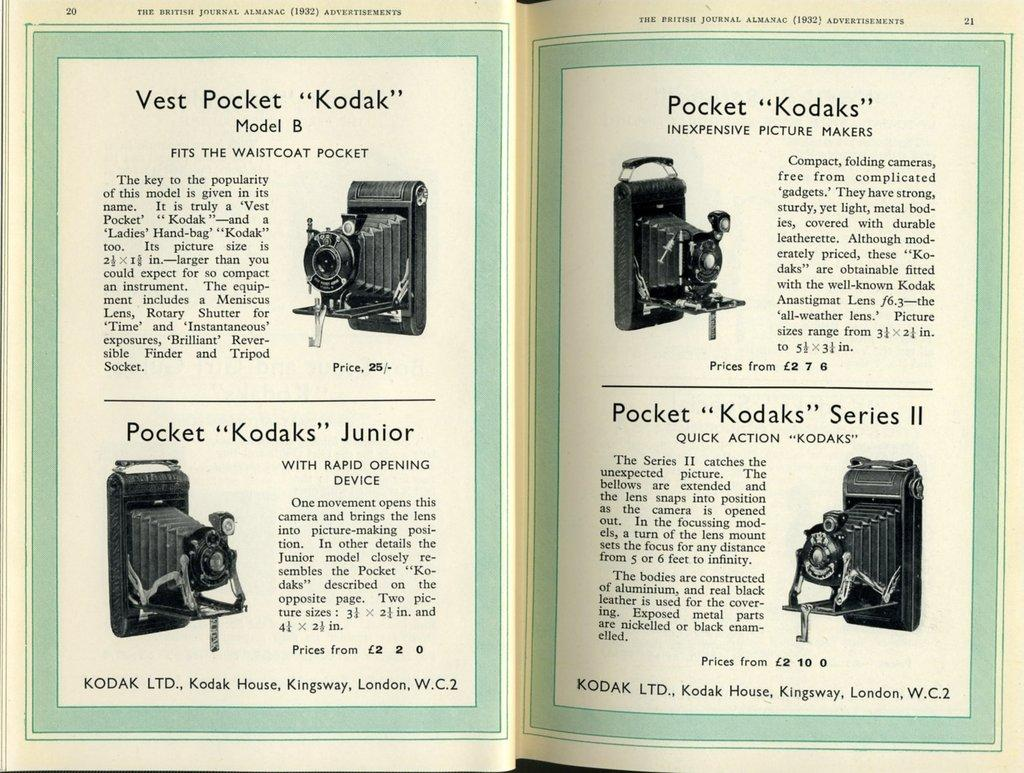What object can be seen in the image related to reading or learning? There is a book in the image. What devices are present in the image that are used for capturing images or videos? There are cameras in the image. Can you describe any written content visible in the image? Yes, there is text visible in the image. What type of coal is being used to fuel the coach in the image? There is no coach or coal present in the image. What is the purpose of the text visible in the image? The purpose of the text visible in the image cannot be determined without additional context. 